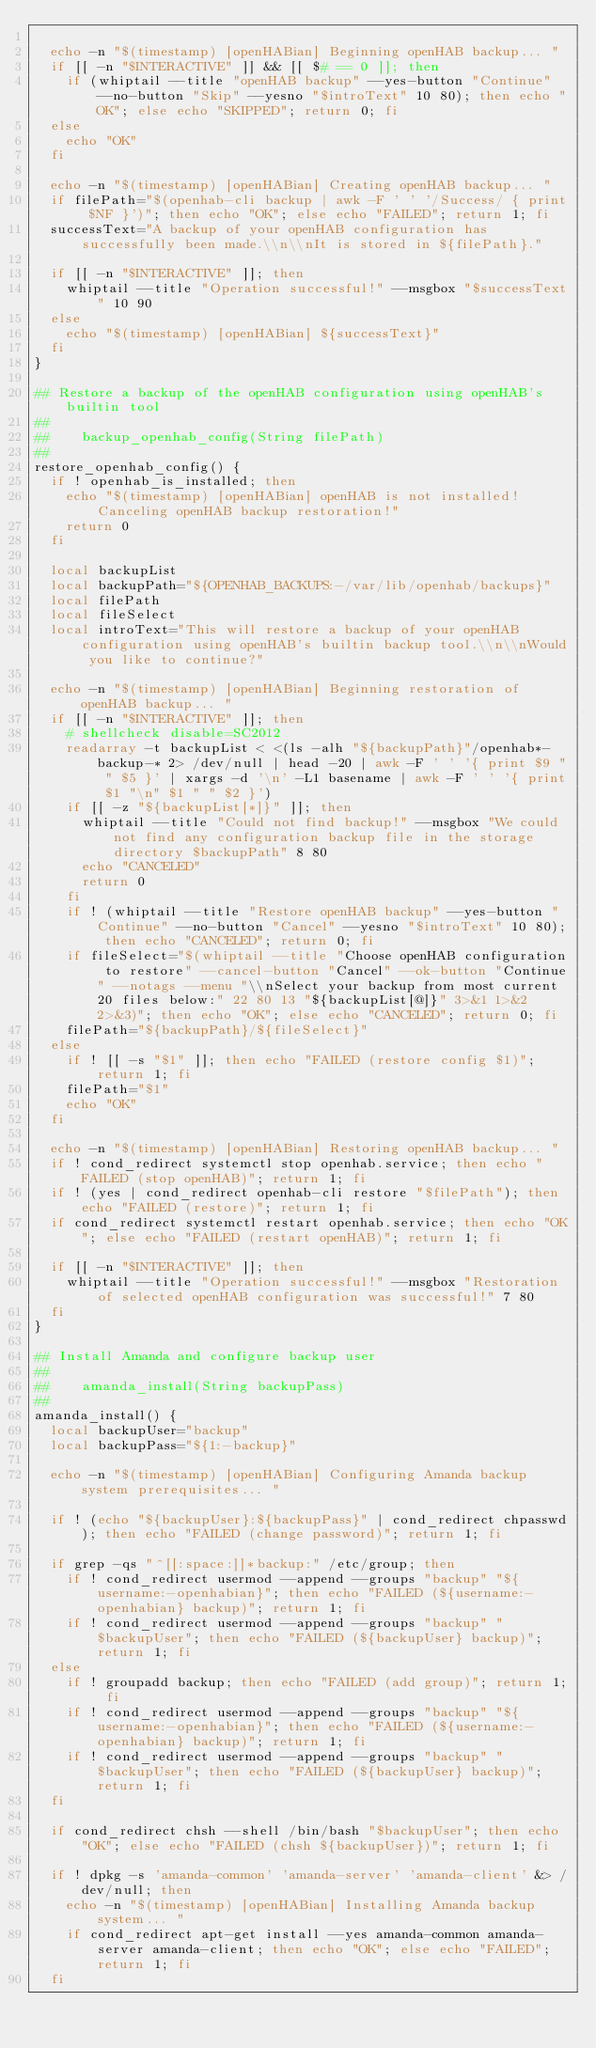<code> <loc_0><loc_0><loc_500><loc_500><_Bash_>
  echo -n "$(timestamp) [openHABian] Beginning openHAB backup... "
  if [[ -n "$INTERACTIVE" ]] && [[ $# == 0 ]]; then
    if (whiptail --title "openHAB backup" --yes-button "Continue" --no-button "Skip" --yesno "$introText" 10 80); then echo "OK"; else echo "SKIPPED"; return 0; fi
  else
    echo "OK"
  fi

  echo -n "$(timestamp) [openHABian] Creating openHAB backup... "
  if filePath="$(openhab-cli backup | awk -F ' ' '/Success/ { print $NF }')"; then echo "OK"; else echo "FAILED"; return 1; fi
  successText="A backup of your openHAB configuration has successfully been made.\\n\\nIt is stored in ${filePath}."

  if [[ -n "$INTERACTIVE" ]]; then
    whiptail --title "Operation successful!" --msgbox "$successText" 10 90
  else
    echo "$(timestamp) [openHABian] ${successText}"
  fi
}

## Restore a backup of the openHAB configuration using openHAB's builtin tool
##
##    backup_openhab_config(String filePath)
##
restore_openhab_config() {
  if ! openhab_is_installed; then
    echo "$(timestamp) [openHABian] openHAB is not installed! Canceling openHAB backup restoration!"
    return 0
  fi

  local backupList
  local backupPath="${OPENHAB_BACKUPS:-/var/lib/openhab/backups}"
  local filePath
  local fileSelect
  local introText="This will restore a backup of your openHAB configuration using openHAB's builtin backup tool.\\n\\nWould you like to continue?"

  echo -n "$(timestamp) [openHABian] Beginning restoration of openHAB backup... "
  if [[ -n "$INTERACTIVE" ]]; then
    # shellcheck disable=SC2012
    readarray -t backupList < <(ls -alh "${backupPath}"/openhab*-backup-* 2> /dev/null | head -20 | awk -F ' ' '{ print $9 " " $5 }' | xargs -d '\n' -L1 basename | awk -F ' ' '{ print $1 "\n" $1 " " $2 }')
    if [[ -z "${backupList[*]}" ]]; then
      whiptail --title "Could not find backup!" --msgbox "We could not find any configuration backup file in the storage directory $backupPath" 8 80
      echo "CANCELED"
      return 0
    fi
    if ! (whiptail --title "Restore openHAB backup" --yes-button "Continue" --no-button "Cancel" --yesno "$introText" 10 80); then echo "CANCELED"; return 0; fi
    if fileSelect="$(whiptail --title "Choose openHAB configuration to restore" --cancel-button "Cancel" --ok-button "Continue" --notags --menu "\\nSelect your backup from most current 20 files below:" 22 80 13 "${backupList[@]}" 3>&1 1>&2 2>&3)"; then echo "OK"; else echo "CANCELED"; return 0; fi
    filePath="${backupPath}/${fileSelect}"
  else
    if ! [[ -s "$1" ]]; then echo "FAILED (restore config $1)"; return 1; fi
    filePath="$1"
    echo "OK"
  fi

  echo -n "$(timestamp) [openHABian] Restoring openHAB backup... "
  if ! cond_redirect systemctl stop openhab.service; then echo "FAILED (stop openHAB)"; return 1; fi
  if ! (yes | cond_redirect openhab-cli restore "$filePath"); then echo "FAILED (restore)"; return 1; fi
  if cond_redirect systemctl restart openhab.service; then echo "OK"; else echo "FAILED (restart openHAB)"; return 1; fi

  if [[ -n "$INTERACTIVE" ]]; then
    whiptail --title "Operation successful!" --msgbox "Restoration of selected openHAB configuration was successful!" 7 80
  fi
}

## Install Amanda and configure backup user
##
##    amanda_install(String backupPass)
##
amanda_install() {
  local backupUser="backup"
  local backupPass="${1:-backup}"

  echo -n "$(timestamp) [openHABian] Configuring Amanda backup system prerequisites... "

  if ! (echo "${backupUser}:${backupPass}" | cond_redirect chpasswd); then echo "FAILED (change password)"; return 1; fi

  if grep -qs "^[[:space:]]*backup:" /etc/group; then
    if ! cond_redirect usermod --append --groups "backup" "${username:-openhabian}"; then echo "FAILED (${username:-openhabian} backup)"; return 1; fi
    if ! cond_redirect usermod --append --groups "backup" "$backupUser"; then echo "FAILED (${backupUser} backup)"; return 1; fi
  else
    if ! groupadd backup; then echo "FAILED (add group)"; return 1; fi
    if ! cond_redirect usermod --append --groups "backup" "${username:-openhabian}"; then echo "FAILED (${username:-openhabian} backup)"; return 1; fi
    if ! cond_redirect usermod --append --groups "backup" "$backupUser"; then echo "FAILED (${backupUser} backup)"; return 1; fi
  fi

  if cond_redirect chsh --shell /bin/bash "$backupUser"; then echo "OK"; else echo "FAILED (chsh ${backupUser})"; return 1; fi

  if ! dpkg -s 'amanda-common' 'amanda-server' 'amanda-client' &> /dev/null; then
    echo -n "$(timestamp) [openHABian] Installing Amanda backup system... "
    if cond_redirect apt-get install --yes amanda-common amanda-server amanda-client; then echo "OK"; else echo "FAILED"; return 1; fi
  fi</code> 